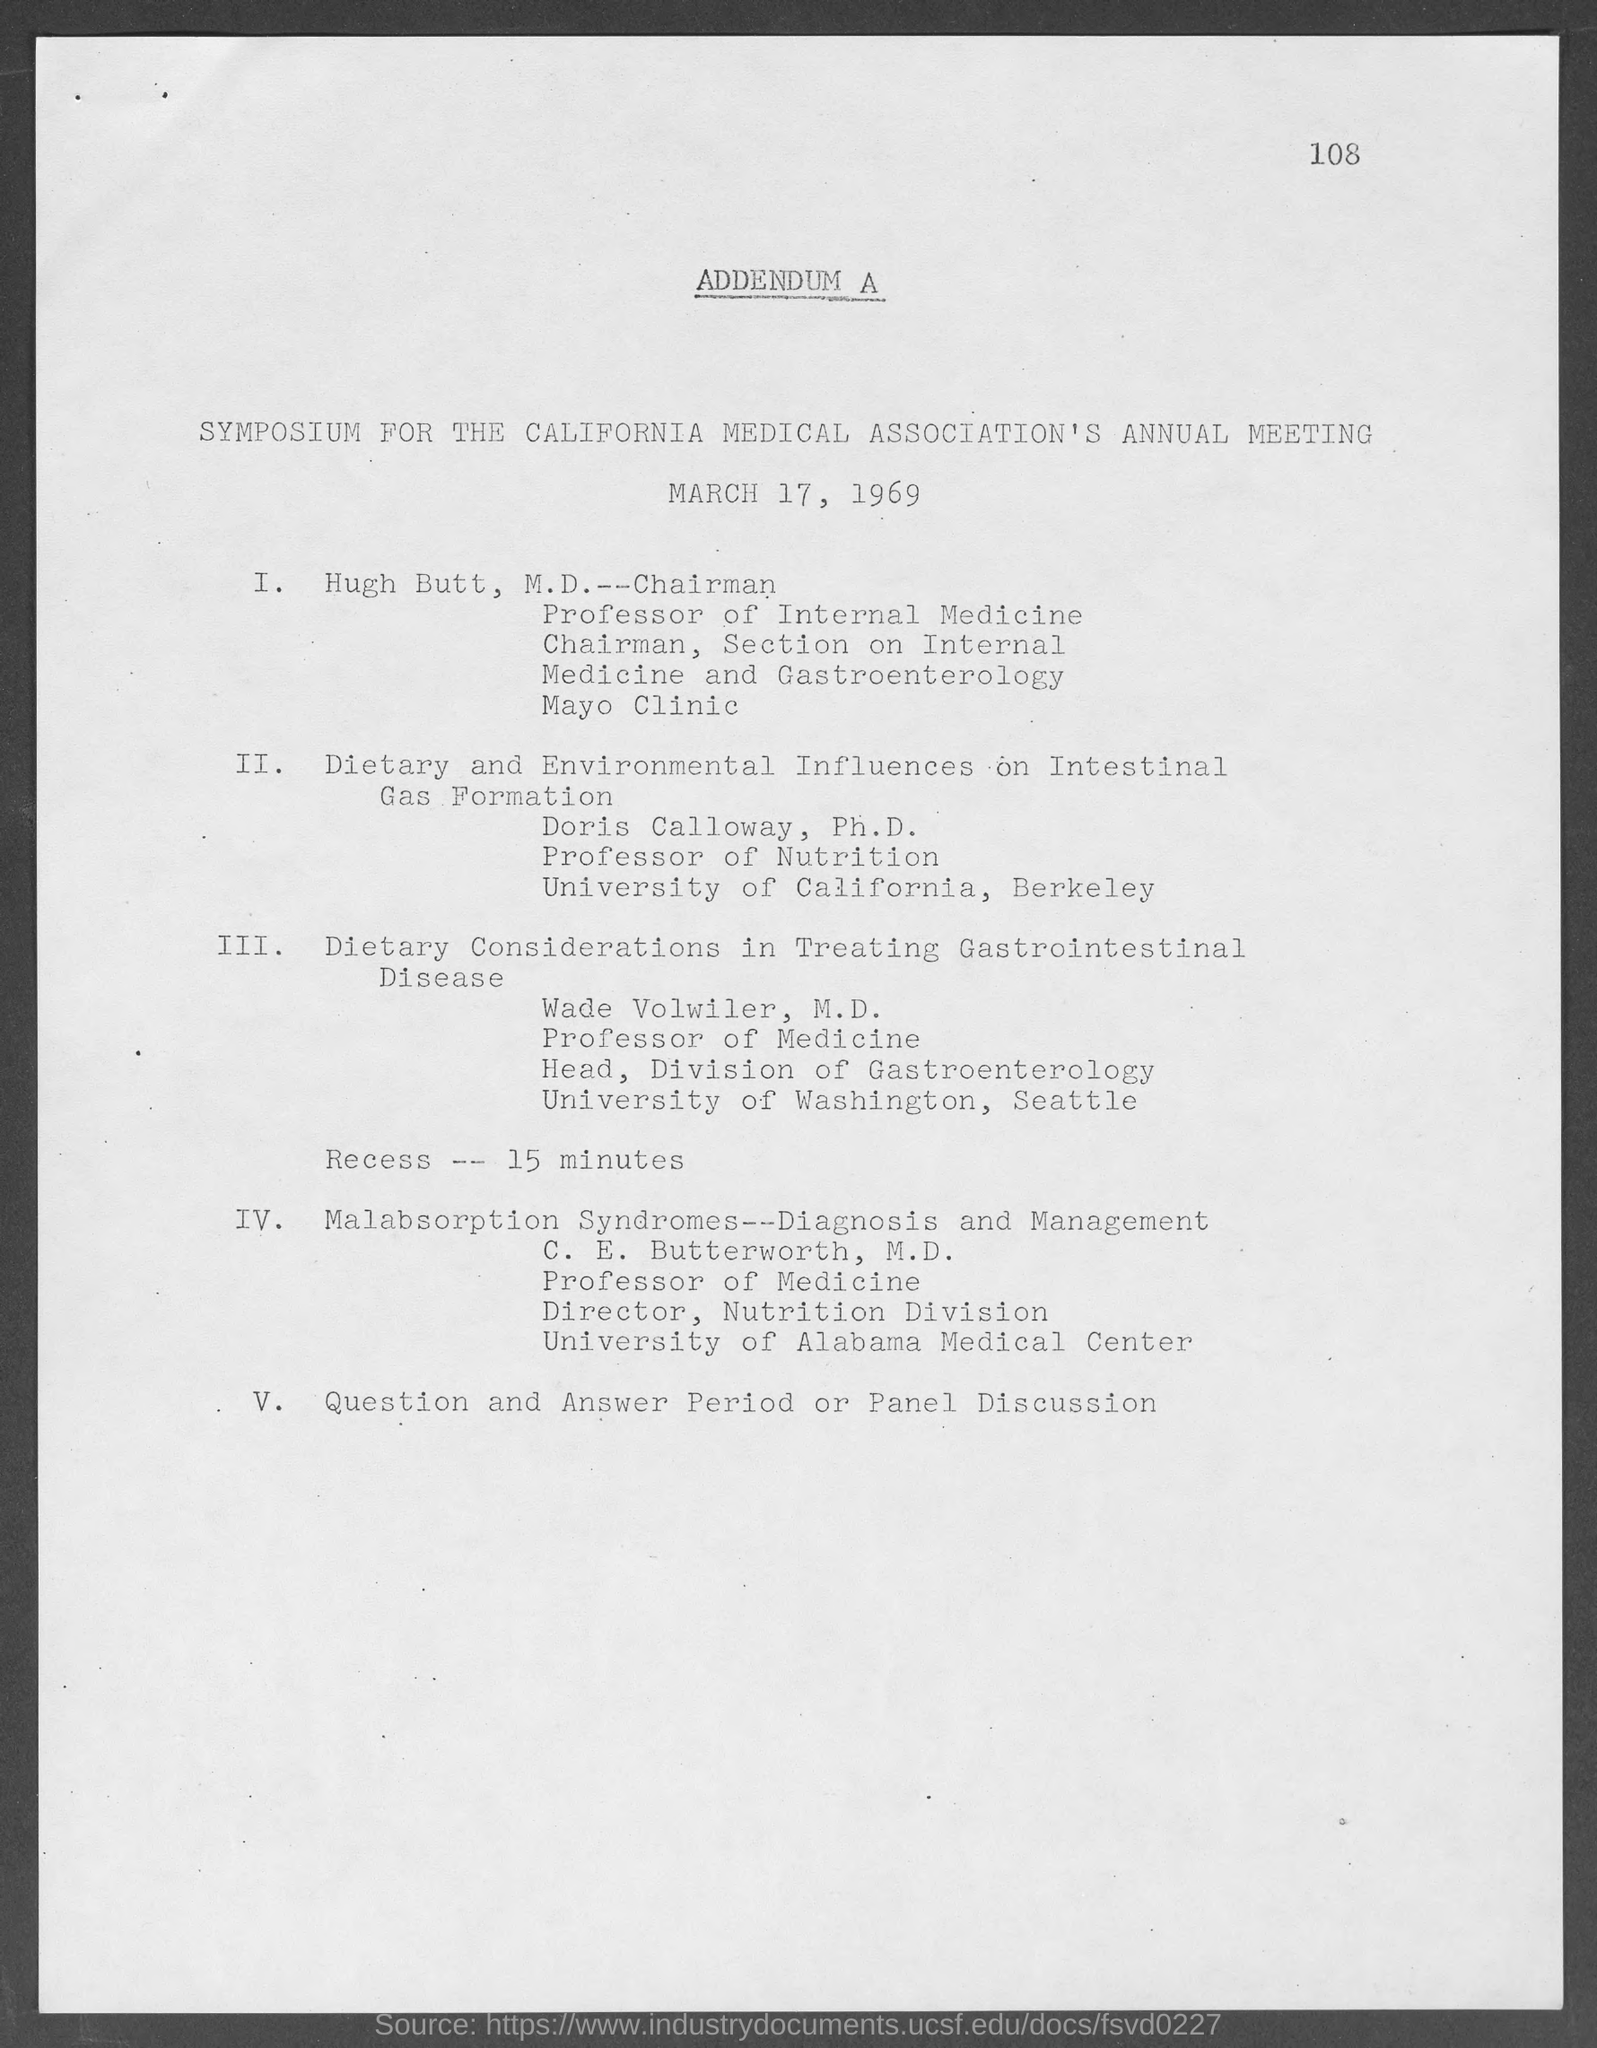Indicate a few pertinent items in this graphic. The date mentioned in the given page is March 17, 1969. 